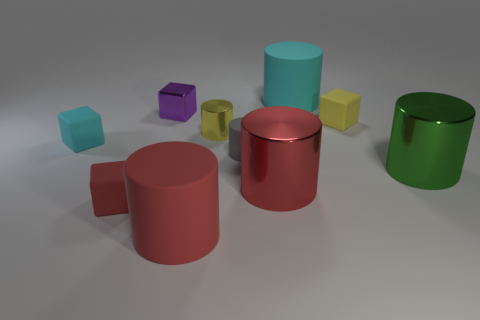How many other things are there of the same material as the small cyan thing?
Keep it short and to the point. 5. What color is the large object that is behind the green metallic thing?
Give a very brief answer. Cyan. Is the color of the small matte block that is on the right side of the tiny red matte cube the same as the tiny shiny cylinder?
Keep it short and to the point. Yes. There is a small yellow object that is the same shape as the purple object; what material is it?
Offer a very short reply. Rubber. What number of yellow rubber cubes are the same size as the purple block?
Provide a short and direct response. 1. What shape is the big cyan thing?
Offer a very short reply. Cylinder. There is a cylinder that is right of the red metallic cylinder and in front of the cyan cylinder; how big is it?
Your answer should be very brief. Large. There is a cyan object to the right of the purple block; what material is it?
Make the answer very short. Rubber. There is a small metallic cylinder; is it the same color as the matte object that is right of the big cyan thing?
Offer a very short reply. Yes. What number of objects are either rubber things behind the small cyan rubber thing or big matte cylinders that are on the right side of the small gray object?
Provide a succinct answer. 2. 